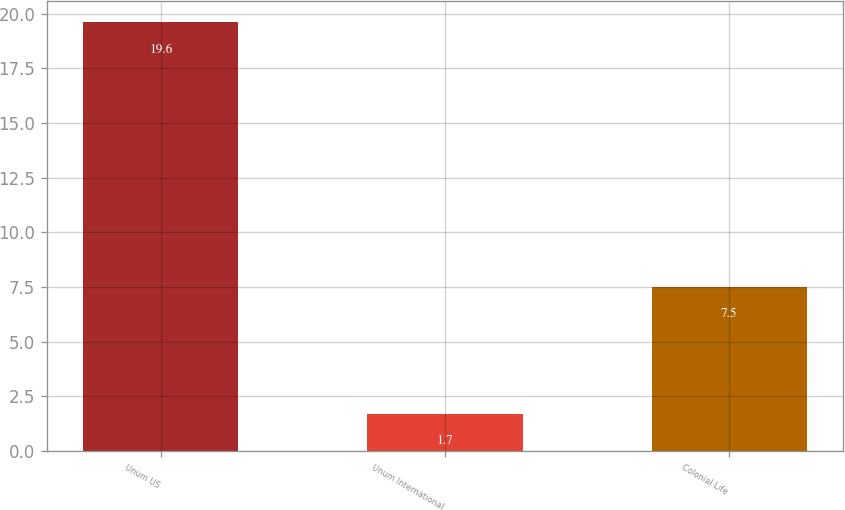Convert chart to OTSL. <chart><loc_0><loc_0><loc_500><loc_500><bar_chart><fcel>Unum US<fcel>Unum International<fcel>Colonial Life<nl><fcel>19.6<fcel>1.7<fcel>7.5<nl></chart> 